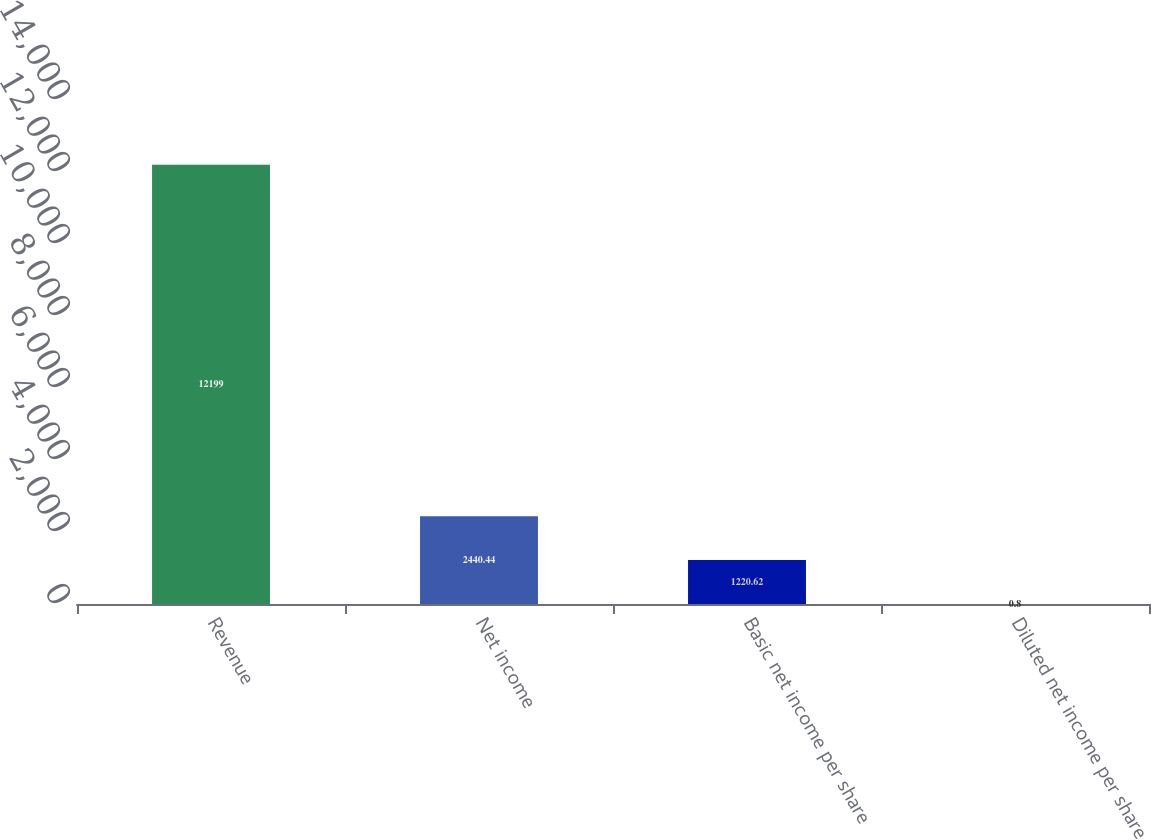<chart> <loc_0><loc_0><loc_500><loc_500><bar_chart><fcel>Revenue<fcel>Net income<fcel>Basic net income per share<fcel>Diluted net income per share<nl><fcel>12199<fcel>2440.44<fcel>1220.62<fcel>0.8<nl></chart> 